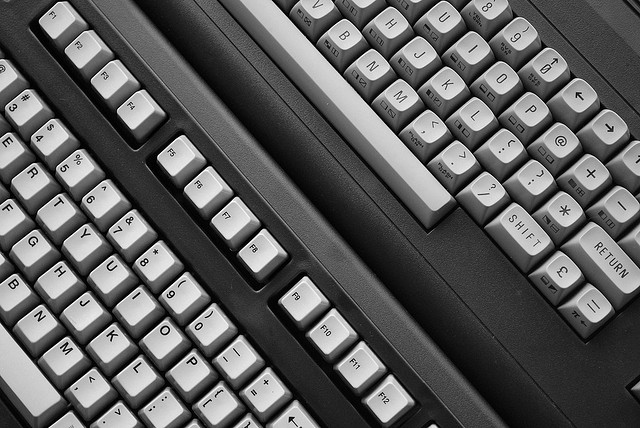How many girl goats are there? The image does not contain any goats, instead, it is a picture of a typewriter keyboard. Therefore, there are no girl goats to count. 